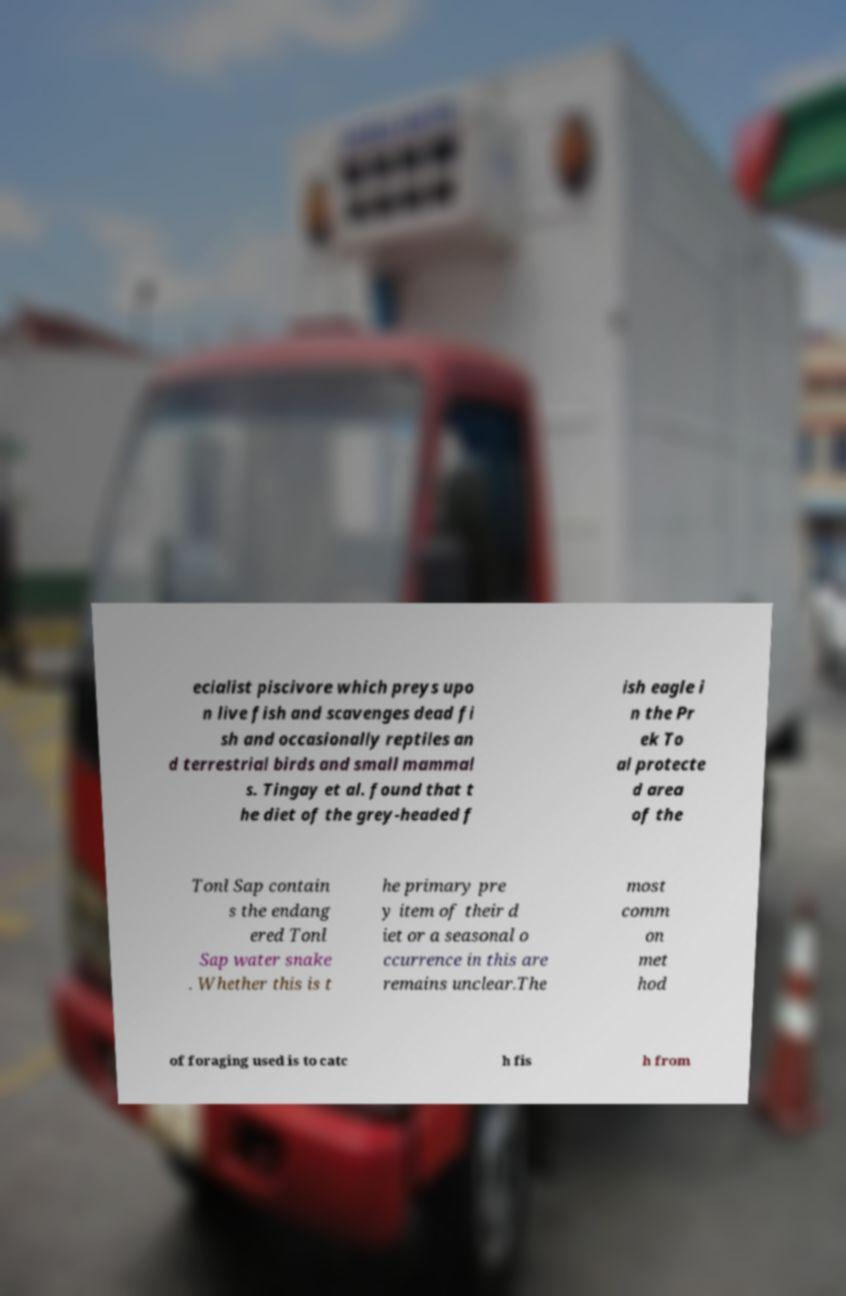Can you read and provide the text displayed in the image?This photo seems to have some interesting text. Can you extract and type it out for me? ecialist piscivore which preys upo n live fish and scavenges dead fi sh and occasionally reptiles an d terrestrial birds and small mammal s. Tingay et al. found that t he diet of the grey-headed f ish eagle i n the Pr ek To al protecte d area of the Tonl Sap contain s the endang ered Tonl Sap water snake . Whether this is t he primary pre y item of their d iet or a seasonal o ccurrence in this are remains unclear.The most comm on met hod of foraging used is to catc h fis h from 